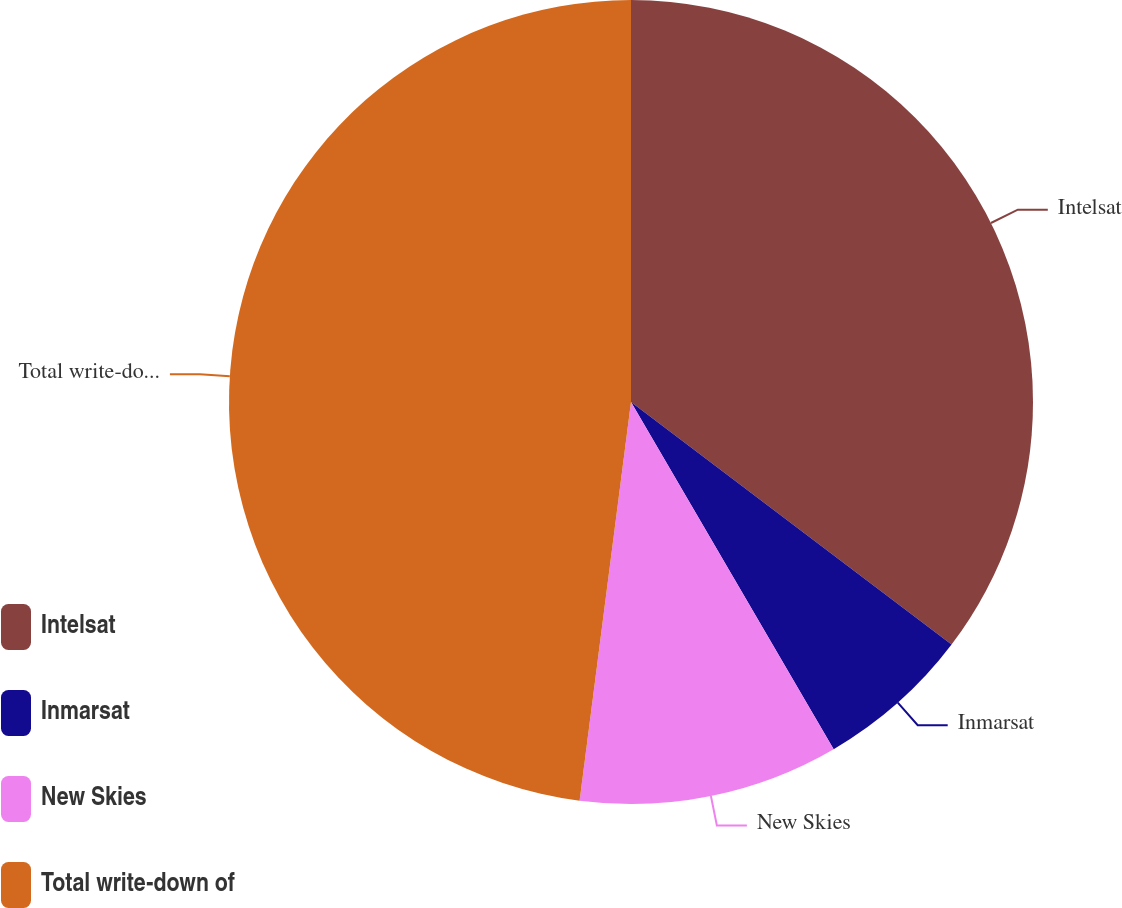Convert chart. <chart><loc_0><loc_0><loc_500><loc_500><pie_chart><fcel>Intelsat<fcel>Inmarsat<fcel>New Skies<fcel>Total write-down of<nl><fcel>35.31%<fcel>6.28%<fcel>10.45%<fcel>47.96%<nl></chart> 